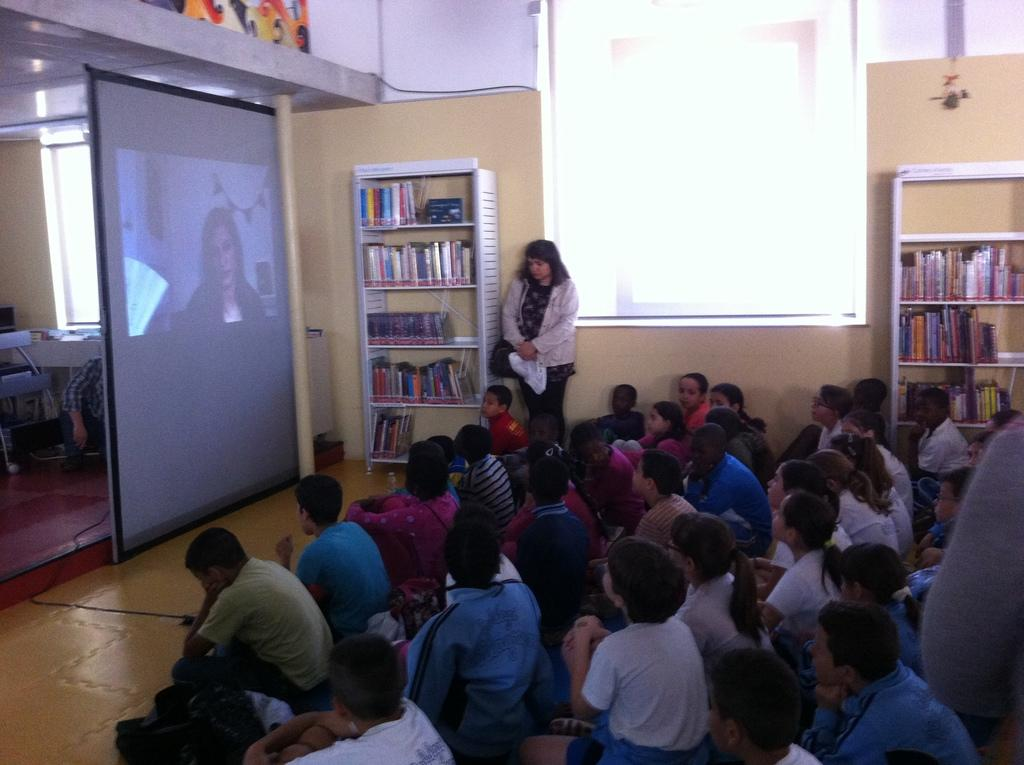Who or what can be seen in the image? There are people in the image. What is the main object or feature in the image? There is a projector screen in the image. What type of structure is present in the image? There is a wall in the image. What can be found on the shelves in the image? There are shelves with books in the image. What is visible beneath the people and objects in the image? The ground is visible in the image. What type of fruit is being discussed by the people in the image? There is no indication of a discussion about fruit in the image. Are there any police officers present in the image? There is no mention of police officers in the image. 